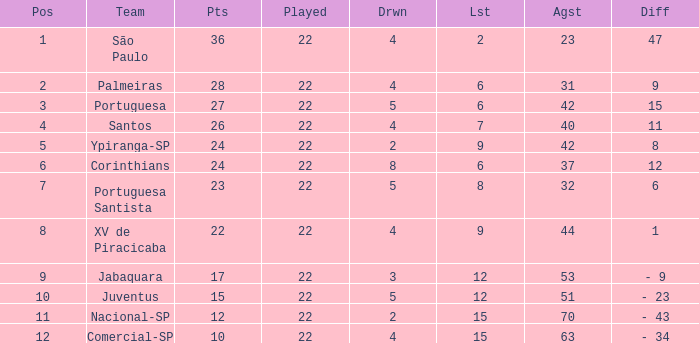Which Against has a Drawn smaller than 5, and a Lost smaller than 6, and a Points larger than 36? 0.0. 